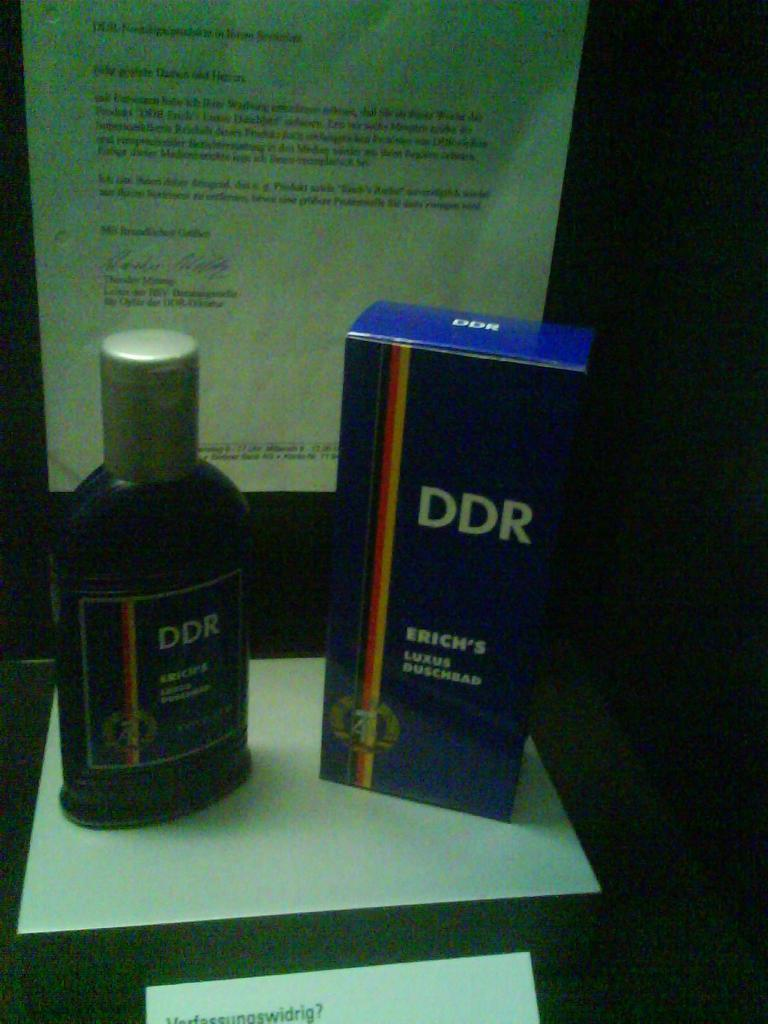<image>
Create a compact narrative representing the image presented. A bottle and a box of DDR are shown in front of a letter. 